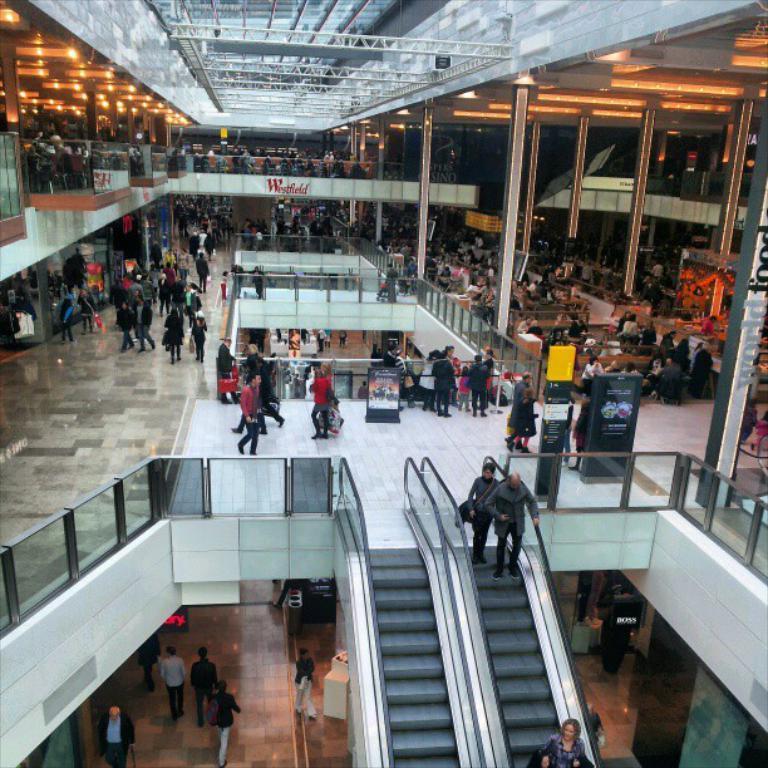How would you summarize this image in a sentence or two? In this image, we can see the inside view of a building. Here we can see people, escalators, banners, pillars, chairs, tables, glass objects and few things. At the top of the image, we can see few rods. Here we can see few people are walking. Few are standing on the escalators. 